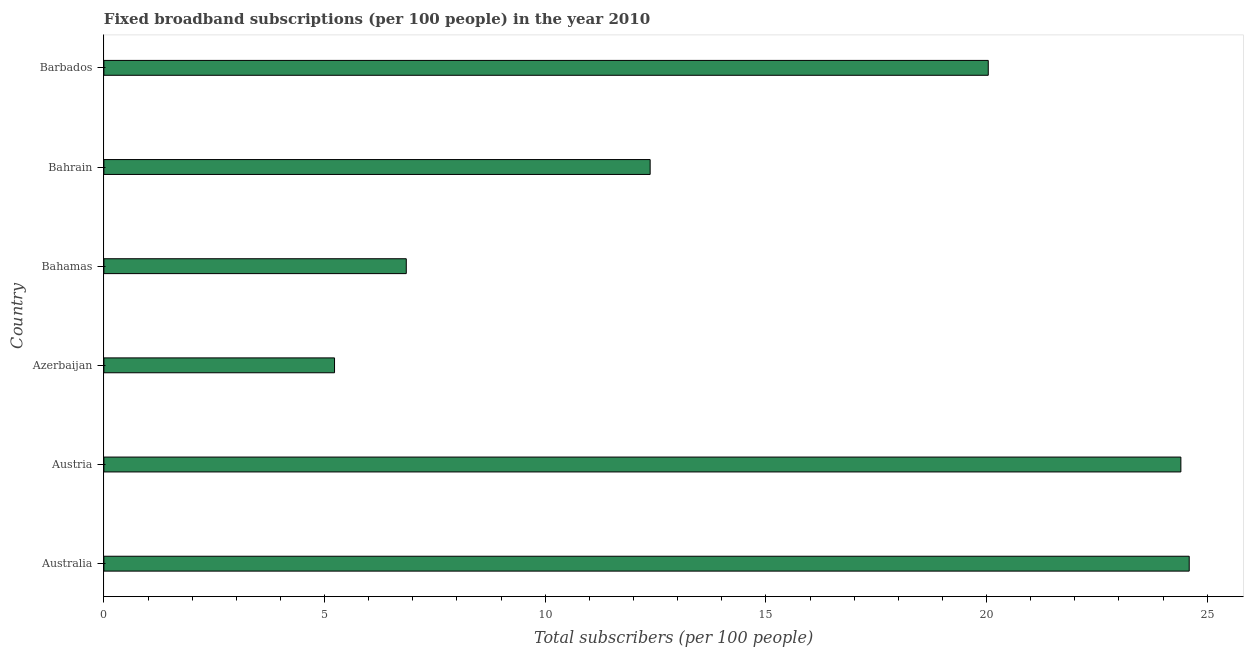Does the graph contain grids?
Provide a short and direct response. No. What is the title of the graph?
Keep it short and to the point. Fixed broadband subscriptions (per 100 people) in the year 2010. What is the label or title of the X-axis?
Your response must be concise. Total subscribers (per 100 people). What is the label or title of the Y-axis?
Your answer should be compact. Country. What is the total number of fixed broadband subscriptions in Barbados?
Ensure brevity in your answer.  20.04. Across all countries, what is the maximum total number of fixed broadband subscriptions?
Ensure brevity in your answer.  24.59. Across all countries, what is the minimum total number of fixed broadband subscriptions?
Make the answer very short. 5.23. In which country was the total number of fixed broadband subscriptions minimum?
Your answer should be very brief. Azerbaijan. What is the sum of the total number of fixed broadband subscriptions?
Keep it short and to the point. 93.49. What is the difference between the total number of fixed broadband subscriptions in Bahrain and Barbados?
Your answer should be very brief. -7.66. What is the average total number of fixed broadband subscriptions per country?
Ensure brevity in your answer.  15.58. What is the median total number of fixed broadband subscriptions?
Your answer should be compact. 16.21. What is the ratio of the total number of fixed broadband subscriptions in Australia to that in Barbados?
Your response must be concise. 1.23. What is the difference between the highest and the second highest total number of fixed broadband subscriptions?
Your answer should be very brief. 0.19. What is the difference between the highest and the lowest total number of fixed broadband subscriptions?
Offer a terse response. 19.37. How many bars are there?
Provide a succinct answer. 6. Are all the bars in the graph horizontal?
Provide a short and direct response. Yes. How many countries are there in the graph?
Give a very brief answer. 6. What is the difference between two consecutive major ticks on the X-axis?
Provide a succinct answer. 5. What is the Total subscribers (per 100 people) in Australia?
Your answer should be very brief. 24.59. What is the Total subscribers (per 100 people) of Austria?
Your response must be concise. 24.4. What is the Total subscribers (per 100 people) in Azerbaijan?
Provide a succinct answer. 5.23. What is the Total subscribers (per 100 people) in Bahamas?
Keep it short and to the point. 6.85. What is the Total subscribers (per 100 people) in Bahrain?
Your response must be concise. 12.38. What is the Total subscribers (per 100 people) of Barbados?
Provide a short and direct response. 20.04. What is the difference between the Total subscribers (per 100 people) in Australia and Austria?
Provide a succinct answer. 0.19. What is the difference between the Total subscribers (per 100 people) in Australia and Azerbaijan?
Ensure brevity in your answer.  19.37. What is the difference between the Total subscribers (per 100 people) in Australia and Bahamas?
Provide a short and direct response. 17.74. What is the difference between the Total subscribers (per 100 people) in Australia and Bahrain?
Offer a terse response. 12.22. What is the difference between the Total subscribers (per 100 people) in Australia and Barbados?
Your answer should be compact. 4.55. What is the difference between the Total subscribers (per 100 people) in Austria and Azerbaijan?
Provide a succinct answer. 19.18. What is the difference between the Total subscribers (per 100 people) in Austria and Bahamas?
Provide a succinct answer. 17.55. What is the difference between the Total subscribers (per 100 people) in Austria and Bahrain?
Provide a succinct answer. 12.03. What is the difference between the Total subscribers (per 100 people) in Austria and Barbados?
Your answer should be compact. 4.36. What is the difference between the Total subscribers (per 100 people) in Azerbaijan and Bahamas?
Provide a succinct answer. -1.63. What is the difference between the Total subscribers (per 100 people) in Azerbaijan and Bahrain?
Your answer should be compact. -7.15. What is the difference between the Total subscribers (per 100 people) in Azerbaijan and Barbados?
Provide a short and direct response. -14.81. What is the difference between the Total subscribers (per 100 people) in Bahamas and Bahrain?
Your answer should be compact. -5.53. What is the difference between the Total subscribers (per 100 people) in Bahamas and Barbados?
Offer a very short reply. -13.19. What is the difference between the Total subscribers (per 100 people) in Bahrain and Barbados?
Provide a succinct answer. -7.66. What is the ratio of the Total subscribers (per 100 people) in Australia to that in Azerbaijan?
Keep it short and to the point. 4.71. What is the ratio of the Total subscribers (per 100 people) in Australia to that in Bahamas?
Ensure brevity in your answer.  3.59. What is the ratio of the Total subscribers (per 100 people) in Australia to that in Bahrain?
Give a very brief answer. 1.99. What is the ratio of the Total subscribers (per 100 people) in Australia to that in Barbados?
Provide a succinct answer. 1.23. What is the ratio of the Total subscribers (per 100 people) in Austria to that in Azerbaijan?
Your response must be concise. 4.67. What is the ratio of the Total subscribers (per 100 people) in Austria to that in Bahamas?
Keep it short and to the point. 3.56. What is the ratio of the Total subscribers (per 100 people) in Austria to that in Bahrain?
Your answer should be compact. 1.97. What is the ratio of the Total subscribers (per 100 people) in Austria to that in Barbados?
Your response must be concise. 1.22. What is the ratio of the Total subscribers (per 100 people) in Azerbaijan to that in Bahamas?
Offer a terse response. 0.76. What is the ratio of the Total subscribers (per 100 people) in Azerbaijan to that in Bahrain?
Ensure brevity in your answer.  0.42. What is the ratio of the Total subscribers (per 100 people) in Azerbaijan to that in Barbados?
Give a very brief answer. 0.26. What is the ratio of the Total subscribers (per 100 people) in Bahamas to that in Bahrain?
Provide a short and direct response. 0.55. What is the ratio of the Total subscribers (per 100 people) in Bahamas to that in Barbados?
Provide a short and direct response. 0.34. What is the ratio of the Total subscribers (per 100 people) in Bahrain to that in Barbados?
Keep it short and to the point. 0.62. 